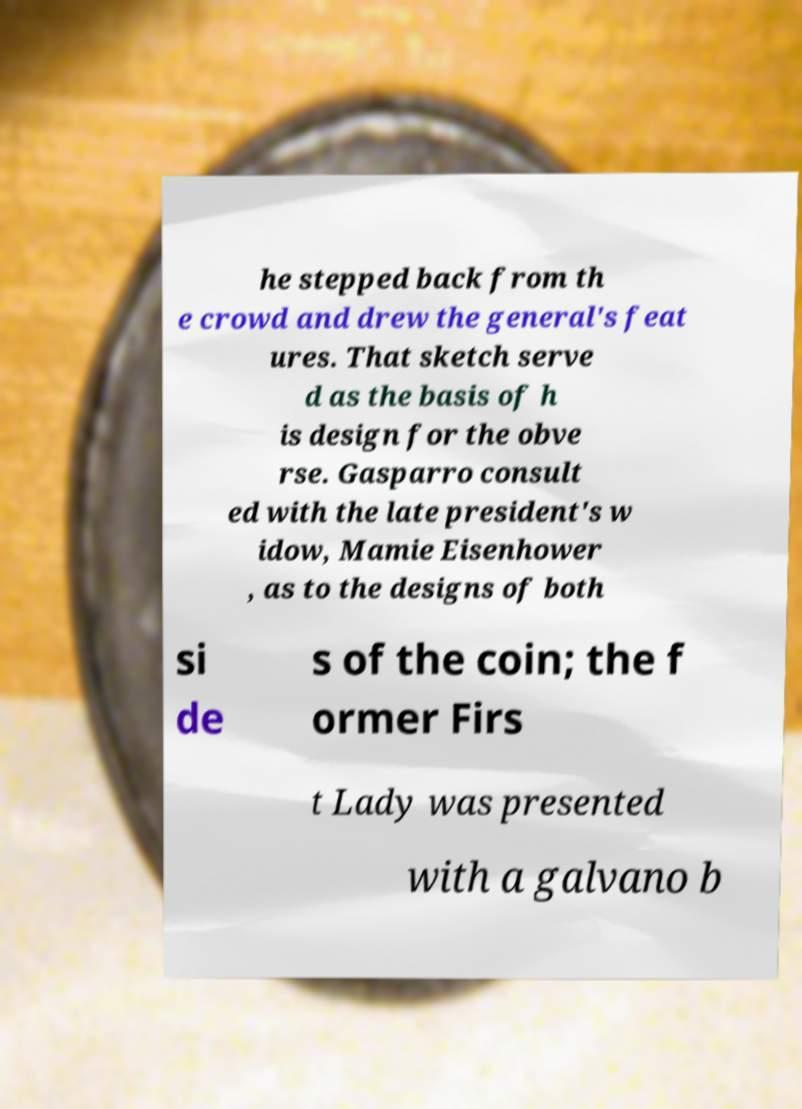There's text embedded in this image that I need extracted. Can you transcribe it verbatim? he stepped back from th e crowd and drew the general's feat ures. That sketch serve d as the basis of h is design for the obve rse. Gasparro consult ed with the late president's w idow, Mamie Eisenhower , as to the designs of both si de s of the coin; the f ormer Firs t Lady was presented with a galvano b 